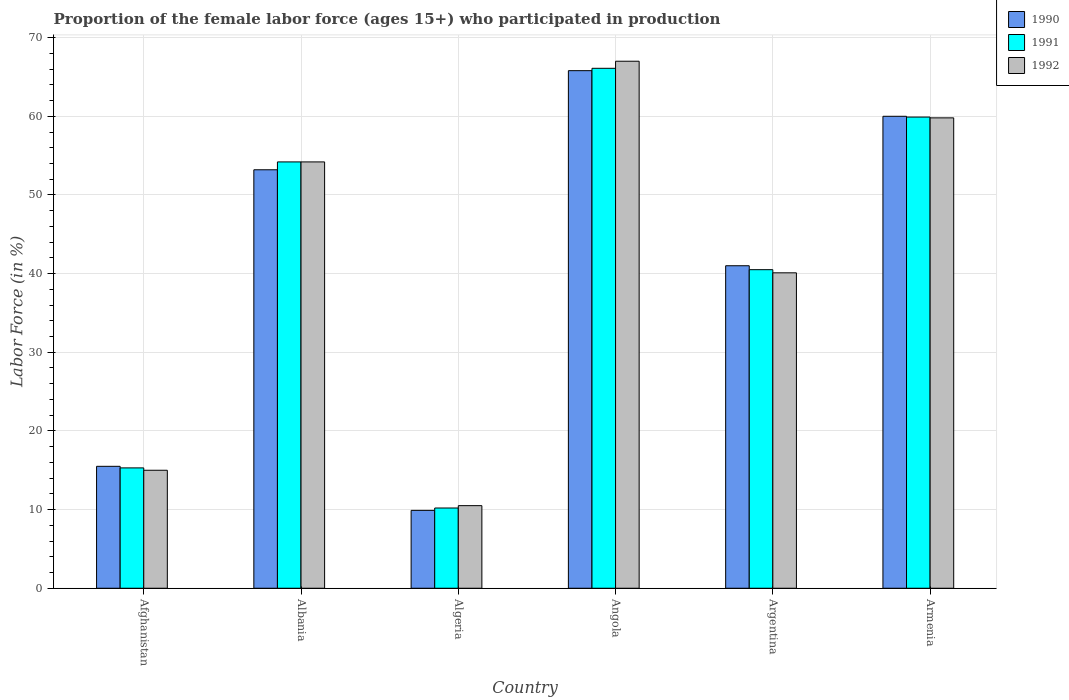Are the number of bars per tick equal to the number of legend labels?
Provide a short and direct response. Yes. How many bars are there on the 6th tick from the left?
Provide a succinct answer. 3. How many bars are there on the 5th tick from the right?
Your response must be concise. 3. What is the label of the 2nd group of bars from the left?
Give a very brief answer. Albania. In how many cases, is the number of bars for a given country not equal to the number of legend labels?
Your answer should be very brief. 0. What is the proportion of the female labor force who participated in production in 1991 in Afghanistan?
Your response must be concise. 15.3. Across all countries, what is the maximum proportion of the female labor force who participated in production in 1991?
Make the answer very short. 66.1. In which country was the proportion of the female labor force who participated in production in 1991 maximum?
Provide a short and direct response. Angola. In which country was the proportion of the female labor force who participated in production in 1991 minimum?
Provide a short and direct response. Algeria. What is the total proportion of the female labor force who participated in production in 1990 in the graph?
Offer a terse response. 245.4. What is the difference between the proportion of the female labor force who participated in production in 1990 in Algeria and that in Angola?
Your answer should be very brief. -55.9. What is the difference between the proportion of the female labor force who participated in production in 1991 in Argentina and the proportion of the female labor force who participated in production in 1992 in Afghanistan?
Make the answer very short. 25.5. What is the average proportion of the female labor force who participated in production in 1990 per country?
Your response must be concise. 40.9. What is the difference between the proportion of the female labor force who participated in production of/in 1990 and proportion of the female labor force who participated in production of/in 1991 in Albania?
Ensure brevity in your answer.  -1. What is the ratio of the proportion of the female labor force who participated in production in 1990 in Algeria to that in Argentina?
Ensure brevity in your answer.  0.24. Is the difference between the proportion of the female labor force who participated in production in 1990 in Albania and Algeria greater than the difference between the proportion of the female labor force who participated in production in 1991 in Albania and Algeria?
Ensure brevity in your answer.  No. What is the difference between the highest and the second highest proportion of the female labor force who participated in production in 1991?
Give a very brief answer. 6.2. What is the difference between the highest and the lowest proportion of the female labor force who participated in production in 1992?
Make the answer very short. 56.5. Is the sum of the proportion of the female labor force who participated in production in 1992 in Afghanistan and Argentina greater than the maximum proportion of the female labor force who participated in production in 1990 across all countries?
Make the answer very short. No. What does the 2nd bar from the right in Armenia represents?
Your answer should be very brief. 1991. Is it the case that in every country, the sum of the proportion of the female labor force who participated in production in 1991 and proportion of the female labor force who participated in production in 1990 is greater than the proportion of the female labor force who participated in production in 1992?
Provide a short and direct response. Yes. How many countries are there in the graph?
Provide a short and direct response. 6. Does the graph contain any zero values?
Make the answer very short. No. How many legend labels are there?
Your answer should be compact. 3. What is the title of the graph?
Make the answer very short. Proportion of the female labor force (ages 15+) who participated in production. What is the label or title of the X-axis?
Give a very brief answer. Country. What is the Labor Force (in %) of 1990 in Afghanistan?
Your answer should be compact. 15.5. What is the Labor Force (in %) in 1991 in Afghanistan?
Offer a very short reply. 15.3. What is the Labor Force (in %) in 1990 in Albania?
Your answer should be very brief. 53.2. What is the Labor Force (in %) of 1991 in Albania?
Keep it short and to the point. 54.2. What is the Labor Force (in %) in 1992 in Albania?
Make the answer very short. 54.2. What is the Labor Force (in %) of 1990 in Algeria?
Your answer should be compact. 9.9. What is the Labor Force (in %) of 1991 in Algeria?
Your answer should be compact. 10.2. What is the Labor Force (in %) of 1990 in Angola?
Provide a short and direct response. 65.8. What is the Labor Force (in %) in 1991 in Angola?
Offer a terse response. 66.1. What is the Labor Force (in %) in 1990 in Argentina?
Offer a terse response. 41. What is the Labor Force (in %) in 1991 in Argentina?
Ensure brevity in your answer.  40.5. What is the Labor Force (in %) of 1992 in Argentina?
Your response must be concise. 40.1. What is the Labor Force (in %) of 1990 in Armenia?
Provide a short and direct response. 60. What is the Labor Force (in %) of 1991 in Armenia?
Keep it short and to the point. 59.9. What is the Labor Force (in %) in 1992 in Armenia?
Keep it short and to the point. 59.8. Across all countries, what is the maximum Labor Force (in %) of 1990?
Keep it short and to the point. 65.8. Across all countries, what is the maximum Labor Force (in %) in 1991?
Provide a short and direct response. 66.1. Across all countries, what is the maximum Labor Force (in %) in 1992?
Your answer should be compact. 67. Across all countries, what is the minimum Labor Force (in %) in 1990?
Keep it short and to the point. 9.9. Across all countries, what is the minimum Labor Force (in %) of 1991?
Provide a short and direct response. 10.2. Across all countries, what is the minimum Labor Force (in %) of 1992?
Provide a succinct answer. 10.5. What is the total Labor Force (in %) in 1990 in the graph?
Provide a short and direct response. 245.4. What is the total Labor Force (in %) of 1991 in the graph?
Offer a terse response. 246.2. What is the total Labor Force (in %) of 1992 in the graph?
Give a very brief answer. 246.6. What is the difference between the Labor Force (in %) in 1990 in Afghanistan and that in Albania?
Give a very brief answer. -37.7. What is the difference between the Labor Force (in %) of 1991 in Afghanistan and that in Albania?
Keep it short and to the point. -38.9. What is the difference between the Labor Force (in %) of 1992 in Afghanistan and that in Albania?
Offer a very short reply. -39.2. What is the difference between the Labor Force (in %) in 1990 in Afghanistan and that in Algeria?
Your answer should be very brief. 5.6. What is the difference between the Labor Force (in %) of 1990 in Afghanistan and that in Angola?
Provide a short and direct response. -50.3. What is the difference between the Labor Force (in %) of 1991 in Afghanistan and that in Angola?
Make the answer very short. -50.8. What is the difference between the Labor Force (in %) in 1992 in Afghanistan and that in Angola?
Provide a succinct answer. -52. What is the difference between the Labor Force (in %) of 1990 in Afghanistan and that in Argentina?
Offer a very short reply. -25.5. What is the difference between the Labor Force (in %) of 1991 in Afghanistan and that in Argentina?
Offer a terse response. -25.2. What is the difference between the Labor Force (in %) of 1992 in Afghanistan and that in Argentina?
Your answer should be very brief. -25.1. What is the difference between the Labor Force (in %) of 1990 in Afghanistan and that in Armenia?
Keep it short and to the point. -44.5. What is the difference between the Labor Force (in %) in 1991 in Afghanistan and that in Armenia?
Ensure brevity in your answer.  -44.6. What is the difference between the Labor Force (in %) of 1992 in Afghanistan and that in Armenia?
Provide a succinct answer. -44.8. What is the difference between the Labor Force (in %) in 1990 in Albania and that in Algeria?
Provide a short and direct response. 43.3. What is the difference between the Labor Force (in %) of 1992 in Albania and that in Algeria?
Ensure brevity in your answer.  43.7. What is the difference between the Labor Force (in %) in 1990 in Albania and that in Angola?
Your response must be concise. -12.6. What is the difference between the Labor Force (in %) in 1990 in Albania and that in Argentina?
Give a very brief answer. 12.2. What is the difference between the Labor Force (in %) of 1992 in Albania and that in Argentina?
Offer a terse response. 14.1. What is the difference between the Labor Force (in %) in 1992 in Albania and that in Armenia?
Ensure brevity in your answer.  -5.6. What is the difference between the Labor Force (in %) in 1990 in Algeria and that in Angola?
Offer a terse response. -55.9. What is the difference between the Labor Force (in %) in 1991 in Algeria and that in Angola?
Your answer should be compact. -55.9. What is the difference between the Labor Force (in %) in 1992 in Algeria and that in Angola?
Make the answer very short. -56.5. What is the difference between the Labor Force (in %) in 1990 in Algeria and that in Argentina?
Your answer should be compact. -31.1. What is the difference between the Labor Force (in %) of 1991 in Algeria and that in Argentina?
Keep it short and to the point. -30.3. What is the difference between the Labor Force (in %) in 1992 in Algeria and that in Argentina?
Your response must be concise. -29.6. What is the difference between the Labor Force (in %) of 1990 in Algeria and that in Armenia?
Keep it short and to the point. -50.1. What is the difference between the Labor Force (in %) of 1991 in Algeria and that in Armenia?
Offer a very short reply. -49.7. What is the difference between the Labor Force (in %) in 1992 in Algeria and that in Armenia?
Provide a short and direct response. -49.3. What is the difference between the Labor Force (in %) of 1990 in Angola and that in Argentina?
Provide a succinct answer. 24.8. What is the difference between the Labor Force (in %) of 1991 in Angola and that in Argentina?
Ensure brevity in your answer.  25.6. What is the difference between the Labor Force (in %) in 1992 in Angola and that in Argentina?
Offer a very short reply. 26.9. What is the difference between the Labor Force (in %) of 1991 in Angola and that in Armenia?
Offer a terse response. 6.2. What is the difference between the Labor Force (in %) in 1992 in Angola and that in Armenia?
Your answer should be very brief. 7.2. What is the difference between the Labor Force (in %) of 1990 in Argentina and that in Armenia?
Ensure brevity in your answer.  -19. What is the difference between the Labor Force (in %) of 1991 in Argentina and that in Armenia?
Offer a very short reply. -19.4. What is the difference between the Labor Force (in %) in 1992 in Argentina and that in Armenia?
Offer a very short reply. -19.7. What is the difference between the Labor Force (in %) of 1990 in Afghanistan and the Labor Force (in %) of 1991 in Albania?
Your response must be concise. -38.7. What is the difference between the Labor Force (in %) in 1990 in Afghanistan and the Labor Force (in %) in 1992 in Albania?
Keep it short and to the point. -38.7. What is the difference between the Labor Force (in %) in 1991 in Afghanistan and the Labor Force (in %) in 1992 in Albania?
Give a very brief answer. -38.9. What is the difference between the Labor Force (in %) in 1990 in Afghanistan and the Labor Force (in %) in 1991 in Algeria?
Give a very brief answer. 5.3. What is the difference between the Labor Force (in %) in 1990 in Afghanistan and the Labor Force (in %) in 1991 in Angola?
Provide a succinct answer. -50.6. What is the difference between the Labor Force (in %) of 1990 in Afghanistan and the Labor Force (in %) of 1992 in Angola?
Make the answer very short. -51.5. What is the difference between the Labor Force (in %) of 1991 in Afghanistan and the Labor Force (in %) of 1992 in Angola?
Provide a short and direct response. -51.7. What is the difference between the Labor Force (in %) in 1990 in Afghanistan and the Labor Force (in %) in 1991 in Argentina?
Offer a very short reply. -25. What is the difference between the Labor Force (in %) in 1990 in Afghanistan and the Labor Force (in %) in 1992 in Argentina?
Make the answer very short. -24.6. What is the difference between the Labor Force (in %) of 1991 in Afghanistan and the Labor Force (in %) of 1992 in Argentina?
Provide a short and direct response. -24.8. What is the difference between the Labor Force (in %) in 1990 in Afghanistan and the Labor Force (in %) in 1991 in Armenia?
Provide a succinct answer. -44.4. What is the difference between the Labor Force (in %) in 1990 in Afghanistan and the Labor Force (in %) in 1992 in Armenia?
Provide a short and direct response. -44.3. What is the difference between the Labor Force (in %) in 1991 in Afghanistan and the Labor Force (in %) in 1992 in Armenia?
Make the answer very short. -44.5. What is the difference between the Labor Force (in %) in 1990 in Albania and the Labor Force (in %) in 1991 in Algeria?
Provide a succinct answer. 43. What is the difference between the Labor Force (in %) of 1990 in Albania and the Labor Force (in %) of 1992 in Algeria?
Your response must be concise. 42.7. What is the difference between the Labor Force (in %) in 1991 in Albania and the Labor Force (in %) in 1992 in Algeria?
Ensure brevity in your answer.  43.7. What is the difference between the Labor Force (in %) of 1990 in Albania and the Labor Force (in %) of 1991 in Angola?
Offer a terse response. -12.9. What is the difference between the Labor Force (in %) in 1991 in Albania and the Labor Force (in %) in 1992 in Angola?
Ensure brevity in your answer.  -12.8. What is the difference between the Labor Force (in %) in 1990 in Albania and the Labor Force (in %) in 1991 in Argentina?
Your response must be concise. 12.7. What is the difference between the Labor Force (in %) in 1990 in Albania and the Labor Force (in %) in 1991 in Armenia?
Your answer should be very brief. -6.7. What is the difference between the Labor Force (in %) in 1991 in Albania and the Labor Force (in %) in 1992 in Armenia?
Make the answer very short. -5.6. What is the difference between the Labor Force (in %) of 1990 in Algeria and the Labor Force (in %) of 1991 in Angola?
Offer a very short reply. -56.2. What is the difference between the Labor Force (in %) of 1990 in Algeria and the Labor Force (in %) of 1992 in Angola?
Your answer should be compact. -57.1. What is the difference between the Labor Force (in %) of 1991 in Algeria and the Labor Force (in %) of 1992 in Angola?
Your answer should be very brief. -56.8. What is the difference between the Labor Force (in %) of 1990 in Algeria and the Labor Force (in %) of 1991 in Argentina?
Provide a short and direct response. -30.6. What is the difference between the Labor Force (in %) of 1990 in Algeria and the Labor Force (in %) of 1992 in Argentina?
Your response must be concise. -30.2. What is the difference between the Labor Force (in %) of 1991 in Algeria and the Labor Force (in %) of 1992 in Argentina?
Your response must be concise. -29.9. What is the difference between the Labor Force (in %) of 1990 in Algeria and the Labor Force (in %) of 1992 in Armenia?
Your answer should be very brief. -49.9. What is the difference between the Labor Force (in %) of 1991 in Algeria and the Labor Force (in %) of 1992 in Armenia?
Keep it short and to the point. -49.6. What is the difference between the Labor Force (in %) of 1990 in Angola and the Labor Force (in %) of 1991 in Argentina?
Your answer should be compact. 25.3. What is the difference between the Labor Force (in %) of 1990 in Angola and the Labor Force (in %) of 1992 in Argentina?
Keep it short and to the point. 25.7. What is the difference between the Labor Force (in %) of 1991 in Angola and the Labor Force (in %) of 1992 in Argentina?
Provide a succinct answer. 26. What is the difference between the Labor Force (in %) of 1990 in Angola and the Labor Force (in %) of 1991 in Armenia?
Offer a very short reply. 5.9. What is the difference between the Labor Force (in %) of 1990 in Angola and the Labor Force (in %) of 1992 in Armenia?
Keep it short and to the point. 6. What is the difference between the Labor Force (in %) of 1990 in Argentina and the Labor Force (in %) of 1991 in Armenia?
Your answer should be very brief. -18.9. What is the difference between the Labor Force (in %) in 1990 in Argentina and the Labor Force (in %) in 1992 in Armenia?
Your response must be concise. -18.8. What is the difference between the Labor Force (in %) of 1991 in Argentina and the Labor Force (in %) of 1992 in Armenia?
Your answer should be very brief. -19.3. What is the average Labor Force (in %) in 1990 per country?
Your answer should be very brief. 40.9. What is the average Labor Force (in %) of 1991 per country?
Ensure brevity in your answer.  41.03. What is the average Labor Force (in %) in 1992 per country?
Ensure brevity in your answer.  41.1. What is the difference between the Labor Force (in %) of 1990 and Labor Force (in %) of 1991 in Afghanistan?
Offer a terse response. 0.2. What is the difference between the Labor Force (in %) of 1990 and Labor Force (in %) of 1992 in Afghanistan?
Provide a short and direct response. 0.5. What is the difference between the Labor Force (in %) in 1991 and Labor Force (in %) in 1992 in Afghanistan?
Make the answer very short. 0.3. What is the difference between the Labor Force (in %) of 1990 and Labor Force (in %) of 1991 in Albania?
Offer a very short reply. -1. What is the difference between the Labor Force (in %) of 1990 and Labor Force (in %) of 1992 in Albania?
Give a very brief answer. -1. What is the difference between the Labor Force (in %) of 1990 and Labor Force (in %) of 1991 in Algeria?
Keep it short and to the point. -0.3. What is the difference between the Labor Force (in %) of 1990 and Labor Force (in %) of 1992 in Algeria?
Your response must be concise. -0.6. What is the difference between the Labor Force (in %) in 1990 and Labor Force (in %) in 1991 in Angola?
Provide a short and direct response. -0.3. What is the difference between the Labor Force (in %) of 1990 and Labor Force (in %) of 1992 in Angola?
Your answer should be very brief. -1.2. What is the difference between the Labor Force (in %) in 1990 and Labor Force (in %) in 1991 in Argentina?
Ensure brevity in your answer.  0.5. What is the difference between the Labor Force (in %) of 1990 and Labor Force (in %) of 1992 in Armenia?
Provide a short and direct response. 0.2. What is the ratio of the Labor Force (in %) of 1990 in Afghanistan to that in Albania?
Ensure brevity in your answer.  0.29. What is the ratio of the Labor Force (in %) of 1991 in Afghanistan to that in Albania?
Your answer should be very brief. 0.28. What is the ratio of the Labor Force (in %) of 1992 in Afghanistan to that in Albania?
Make the answer very short. 0.28. What is the ratio of the Labor Force (in %) of 1990 in Afghanistan to that in Algeria?
Your answer should be very brief. 1.57. What is the ratio of the Labor Force (in %) in 1992 in Afghanistan to that in Algeria?
Provide a succinct answer. 1.43. What is the ratio of the Labor Force (in %) in 1990 in Afghanistan to that in Angola?
Ensure brevity in your answer.  0.24. What is the ratio of the Labor Force (in %) of 1991 in Afghanistan to that in Angola?
Give a very brief answer. 0.23. What is the ratio of the Labor Force (in %) in 1992 in Afghanistan to that in Angola?
Your answer should be very brief. 0.22. What is the ratio of the Labor Force (in %) of 1990 in Afghanistan to that in Argentina?
Offer a very short reply. 0.38. What is the ratio of the Labor Force (in %) in 1991 in Afghanistan to that in Argentina?
Keep it short and to the point. 0.38. What is the ratio of the Labor Force (in %) in 1992 in Afghanistan to that in Argentina?
Your answer should be compact. 0.37. What is the ratio of the Labor Force (in %) in 1990 in Afghanistan to that in Armenia?
Your answer should be very brief. 0.26. What is the ratio of the Labor Force (in %) in 1991 in Afghanistan to that in Armenia?
Keep it short and to the point. 0.26. What is the ratio of the Labor Force (in %) of 1992 in Afghanistan to that in Armenia?
Provide a succinct answer. 0.25. What is the ratio of the Labor Force (in %) of 1990 in Albania to that in Algeria?
Ensure brevity in your answer.  5.37. What is the ratio of the Labor Force (in %) of 1991 in Albania to that in Algeria?
Ensure brevity in your answer.  5.31. What is the ratio of the Labor Force (in %) of 1992 in Albania to that in Algeria?
Provide a succinct answer. 5.16. What is the ratio of the Labor Force (in %) of 1990 in Albania to that in Angola?
Provide a short and direct response. 0.81. What is the ratio of the Labor Force (in %) of 1991 in Albania to that in Angola?
Your answer should be very brief. 0.82. What is the ratio of the Labor Force (in %) in 1992 in Albania to that in Angola?
Make the answer very short. 0.81. What is the ratio of the Labor Force (in %) in 1990 in Albania to that in Argentina?
Provide a short and direct response. 1.3. What is the ratio of the Labor Force (in %) in 1991 in Albania to that in Argentina?
Provide a short and direct response. 1.34. What is the ratio of the Labor Force (in %) of 1992 in Albania to that in Argentina?
Ensure brevity in your answer.  1.35. What is the ratio of the Labor Force (in %) of 1990 in Albania to that in Armenia?
Provide a succinct answer. 0.89. What is the ratio of the Labor Force (in %) of 1991 in Albania to that in Armenia?
Keep it short and to the point. 0.9. What is the ratio of the Labor Force (in %) of 1992 in Albania to that in Armenia?
Offer a very short reply. 0.91. What is the ratio of the Labor Force (in %) of 1990 in Algeria to that in Angola?
Provide a succinct answer. 0.15. What is the ratio of the Labor Force (in %) of 1991 in Algeria to that in Angola?
Ensure brevity in your answer.  0.15. What is the ratio of the Labor Force (in %) of 1992 in Algeria to that in Angola?
Offer a terse response. 0.16. What is the ratio of the Labor Force (in %) of 1990 in Algeria to that in Argentina?
Make the answer very short. 0.24. What is the ratio of the Labor Force (in %) of 1991 in Algeria to that in Argentina?
Ensure brevity in your answer.  0.25. What is the ratio of the Labor Force (in %) of 1992 in Algeria to that in Argentina?
Provide a succinct answer. 0.26. What is the ratio of the Labor Force (in %) in 1990 in Algeria to that in Armenia?
Give a very brief answer. 0.17. What is the ratio of the Labor Force (in %) of 1991 in Algeria to that in Armenia?
Give a very brief answer. 0.17. What is the ratio of the Labor Force (in %) of 1992 in Algeria to that in Armenia?
Keep it short and to the point. 0.18. What is the ratio of the Labor Force (in %) in 1990 in Angola to that in Argentina?
Your response must be concise. 1.6. What is the ratio of the Labor Force (in %) in 1991 in Angola to that in Argentina?
Provide a short and direct response. 1.63. What is the ratio of the Labor Force (in %) of 1992 in Angola to that in Argentina?
Make the answer very short. 1.67. What is the ratio of the Labor Force (in %) in 1990 in Angola to that in Armenia?
Keep it short and to the point. 1.1. What is the ratio of the Labor Force (in %) in 1991 in Angola to that in Armenia?
Ensure brevity in your answer.  1.1. What is the ratio of the Labor Force (in %) in 1992 in Angola to that in Armenia?
Ensure brevity in your answer.  1.12. What is the ratio of the Labor Force (in %) in 1990 in Argentina to that in Armenia?
Offer a terse response. 0.68. What is the ratio of the Labor Force (in %) of 1991 in Argentina to that in Armenia?
Your response must be concise. 0.68. What is the ratio of the Labor Force (in %) of 1992 in Argentina to that in Armenia?
Offer a very short reply. 0.67. What is the difference between the highest and the second highest Labor Force (in %) of 1990?
Your answer should be very brief. 5.8. What is the difference between the highest and the second highest Labor Force (in %) of 1991?
Your response must be concise. 6.2. What is the difference between the highest and the second highest Labor Force (in %) of 1992?
Give a very brief answer. 7.2. What is the difference between the highest and the lowest Labor Force (in %) of 1990?
Offer a very short reply. 55.9. What is the difference between the highest and the lowest Labor Force (in %) in 1991?
Ensure brevity in your answer.  55.9. What is the difference between the highest and the lowest Labor Force (in %) in 1992?
Make the answer very short. 56.5. 